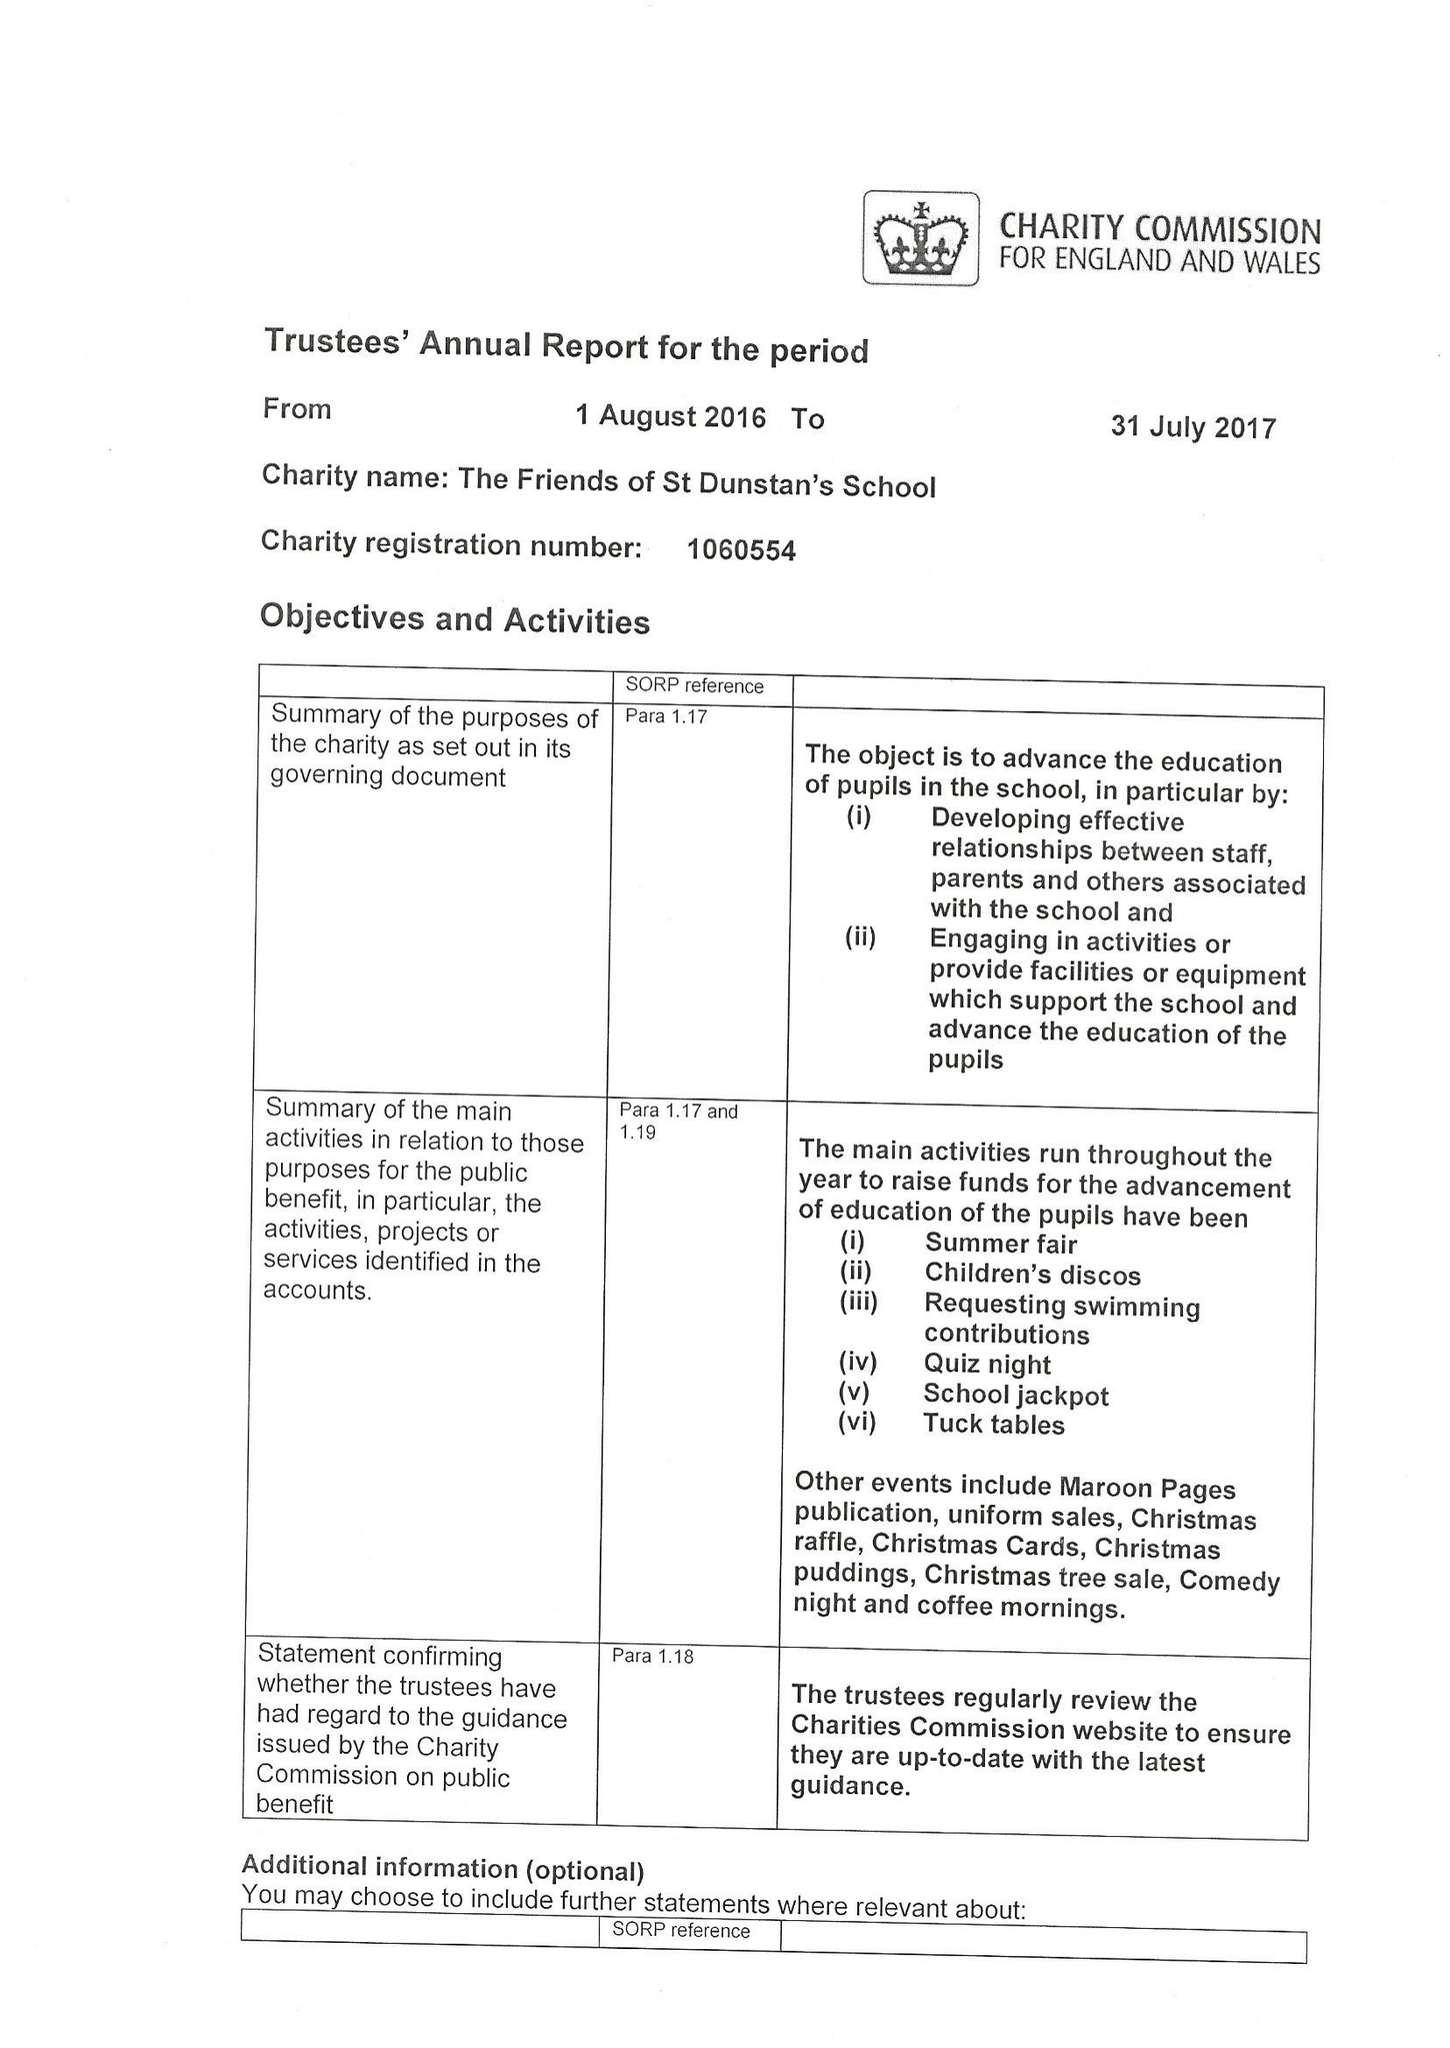What is the value for the spending_annually_in_british_pounds?
Answer the question using a single word or phrase. 38060.00 